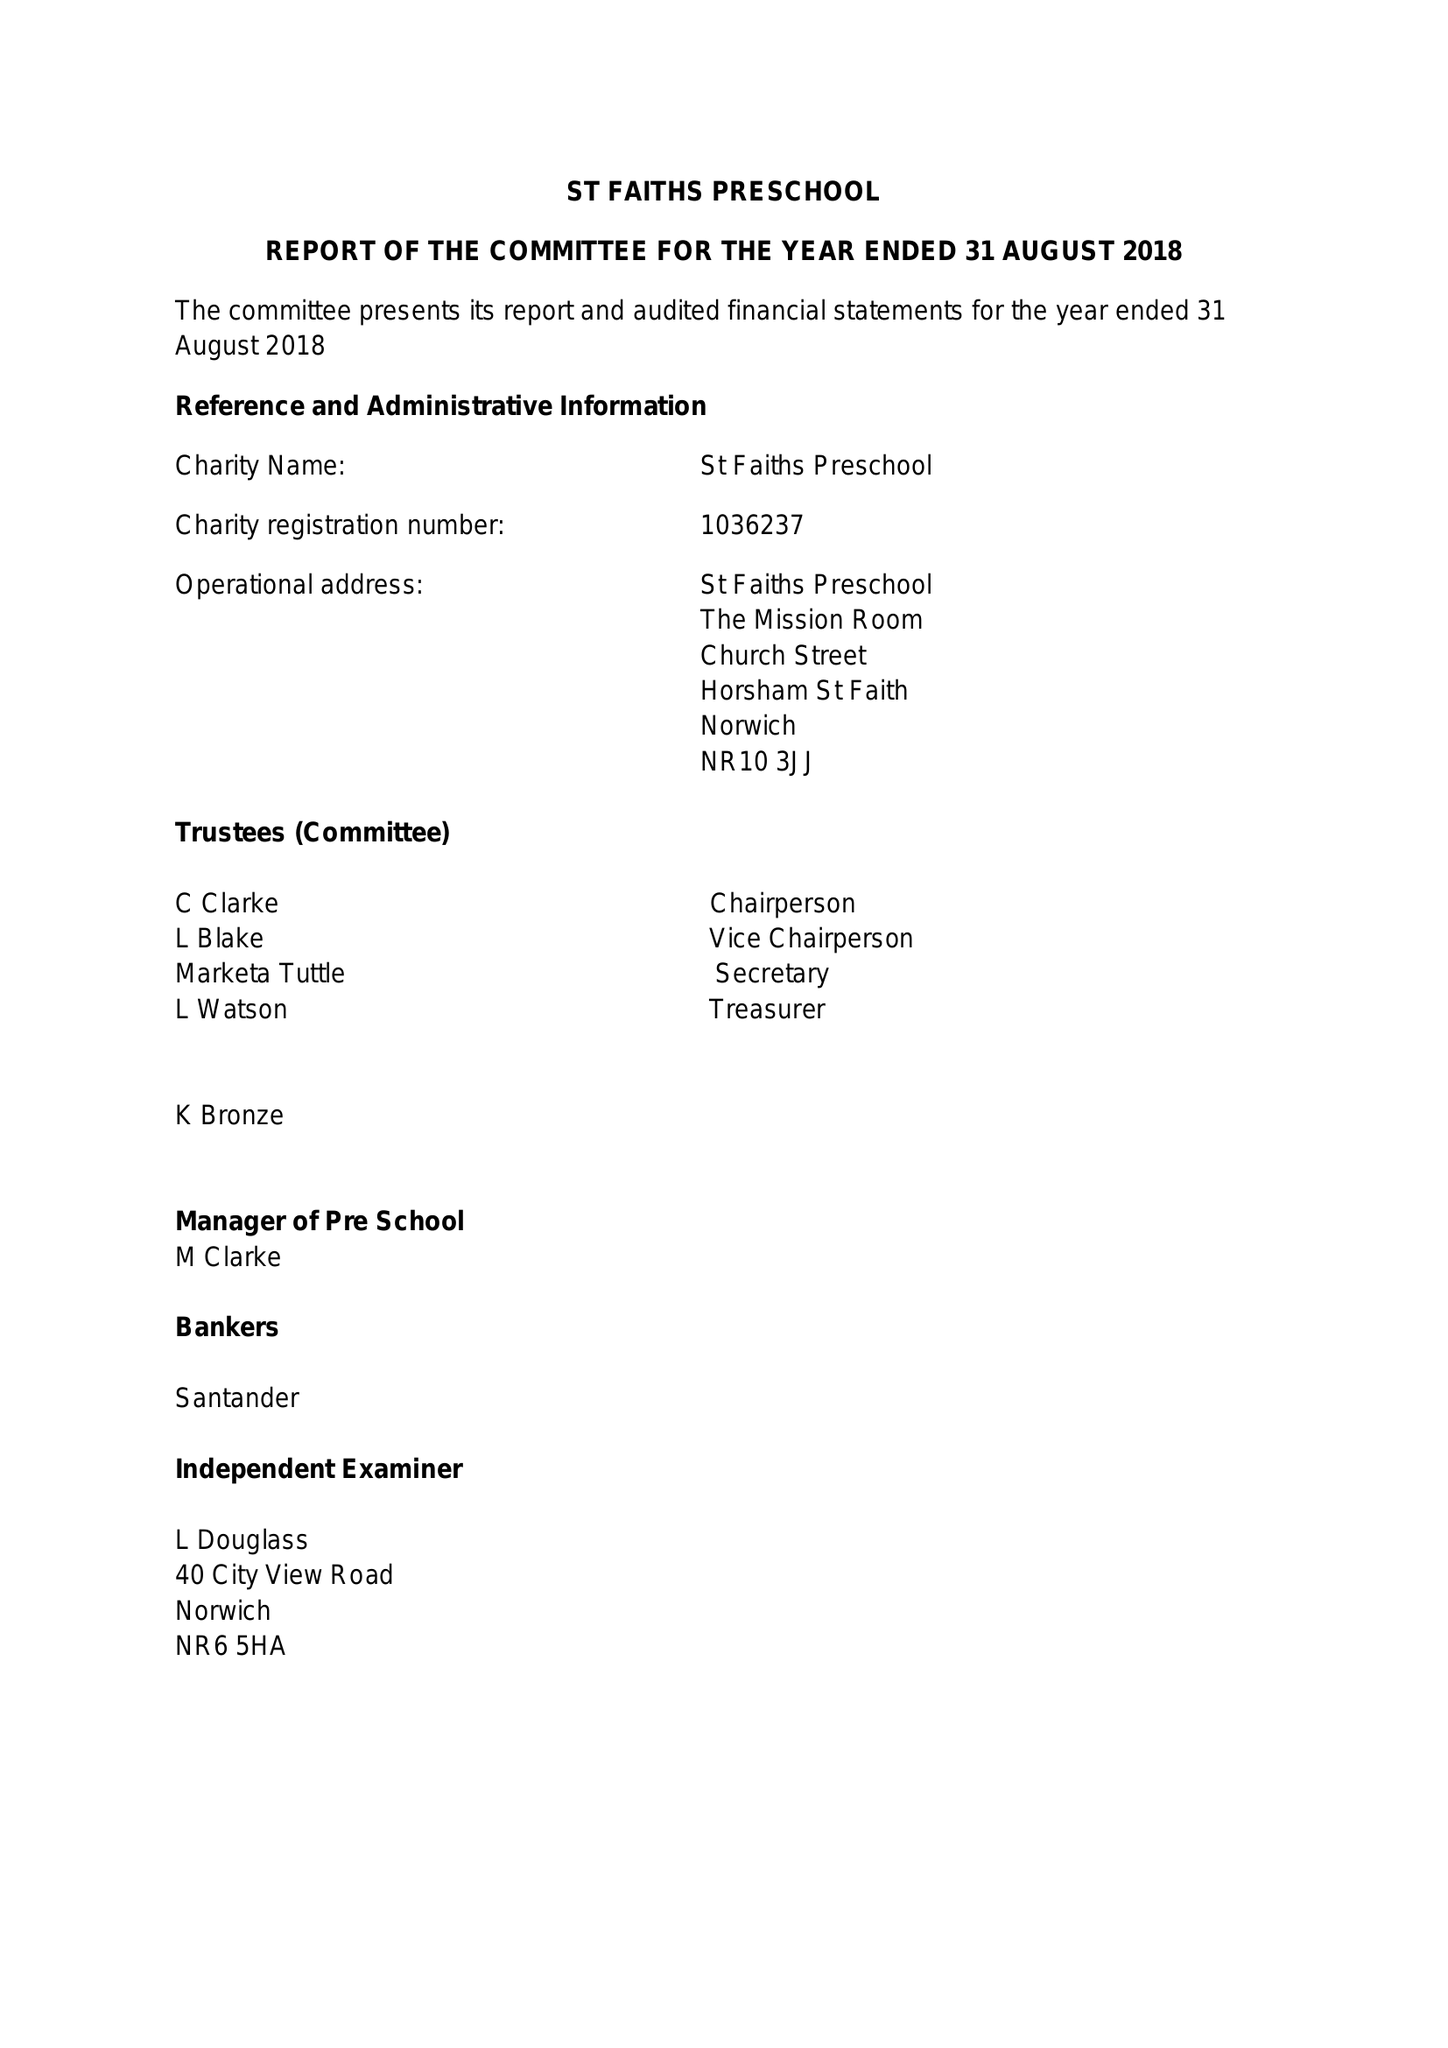What is the value for the spending_annually_in_british_pounds?
Answer the question using a single word or phrase. 33309.00 